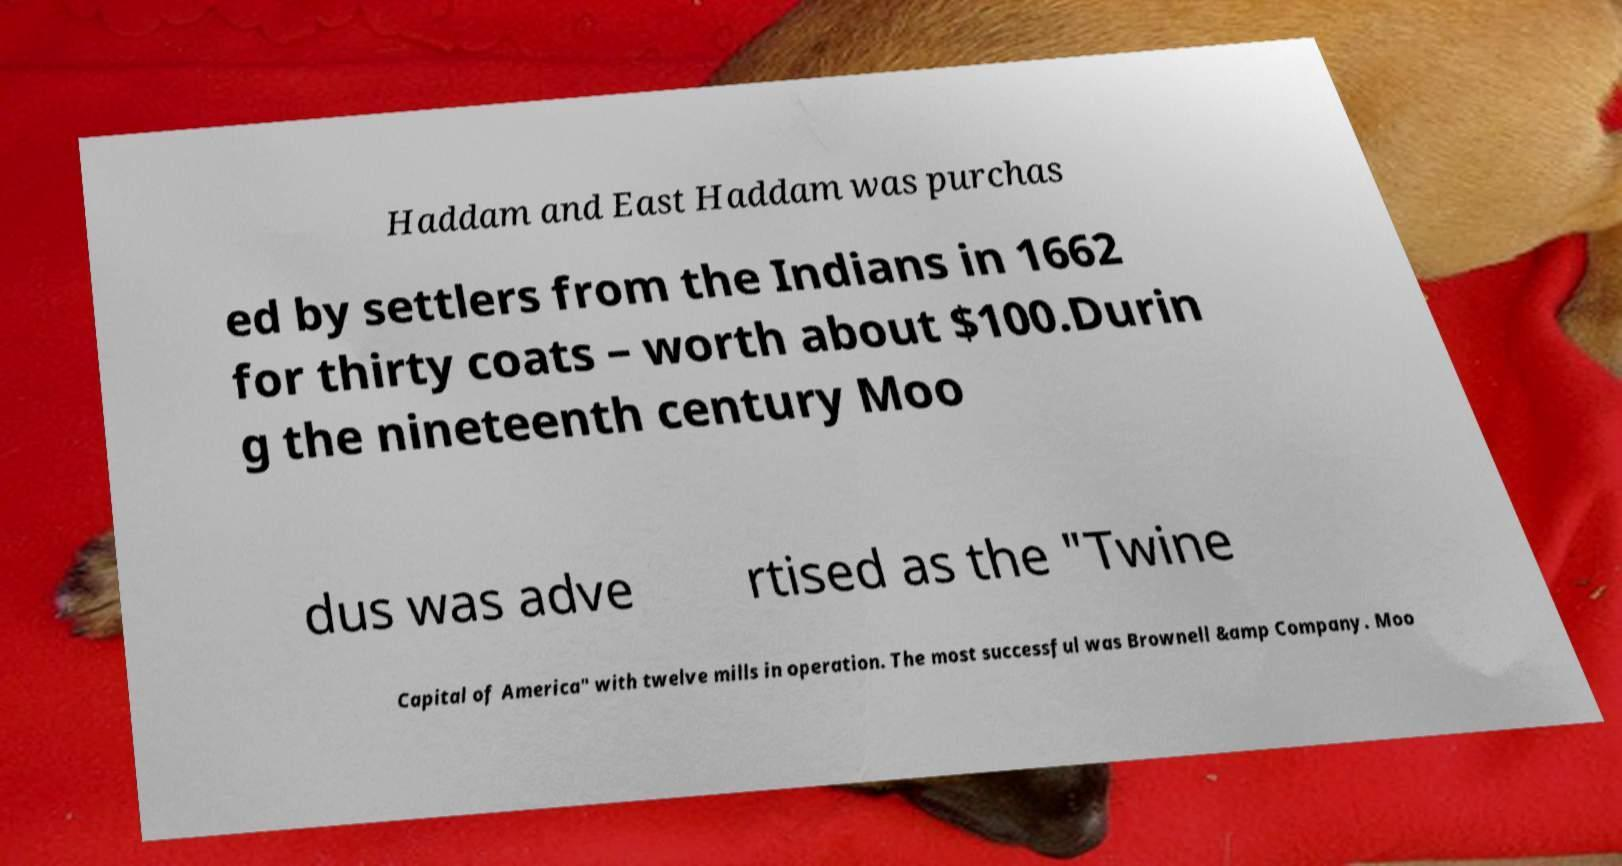Could you extract and type out the text from this image? Haddam and East Haddam was purchas ed by settlers from the Indians in 1662 for thirty coats – worth about $100.Durin g the nineteenth century Moo dus was adve rtised as the "Twine Capital of America" with twelve mills in operation. The most successful was Brownell &amp Company. Moo 